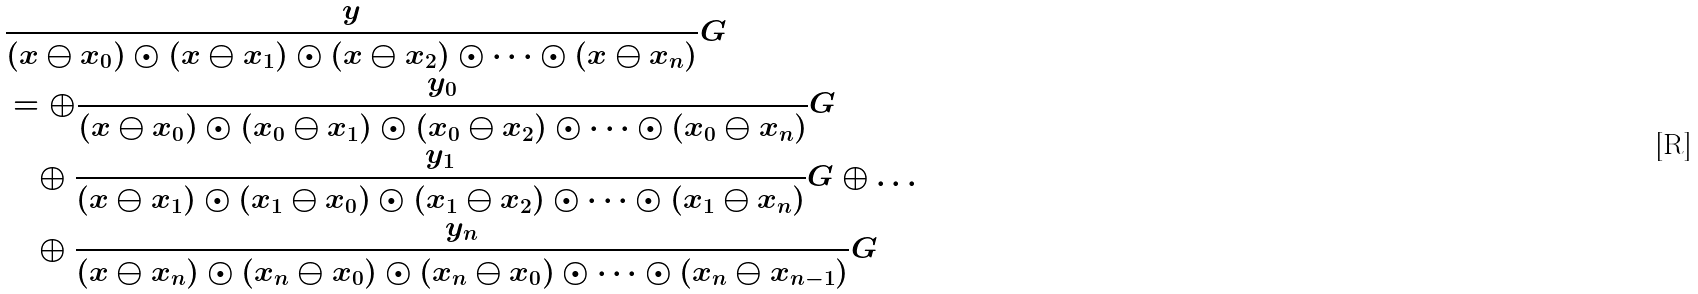Convert formula to latex. <formula><loc_0><loc_0><loc_500><loc_500>& \frac { y } { ( x \ominus x _ { 0 } ) \odot ( x \ominus x _ { 1 } ) \odot ( x \ominus x _ { 2 } ) \odot \dots \odot ( x \ominus x _ { n } ) } G \\ & = \oplus \frac { y _ { 0 } } { ( x \ominus x _ { 0 } ) \odot ( x _ { 0 } \ominus x _ { 1 } ) \odot ( x _ { 0 } \ominus x _ { 2 } ) \odot \dots \odot ( x _ { 0 } \ominus x _ { n } ) } G \\ & \quad \oplus \frac { y _ { 1 } } { ( x \ominus x _ { 1 } ) \odot ( x _ { 1 } \ominus x _ { 0 } ) \odot ( x _ { 1 } \ominus x _ { 2 } ) \odot \dots \odot ( x _ { 1 } \ominus x _ { n } ) } G \oplus \dots \\ & \quad \oplus \frac { y _ { n } } { ( x \ominus x _ { n } ) \odot ( x _ { n } \ominus x _ { 0 } ) \odot ( x _ { n } \ominus x _ { 0 } ) \odot \dots \odot ( x _ { n } \ominus x _ { n - 1 } ) } G</formula> 